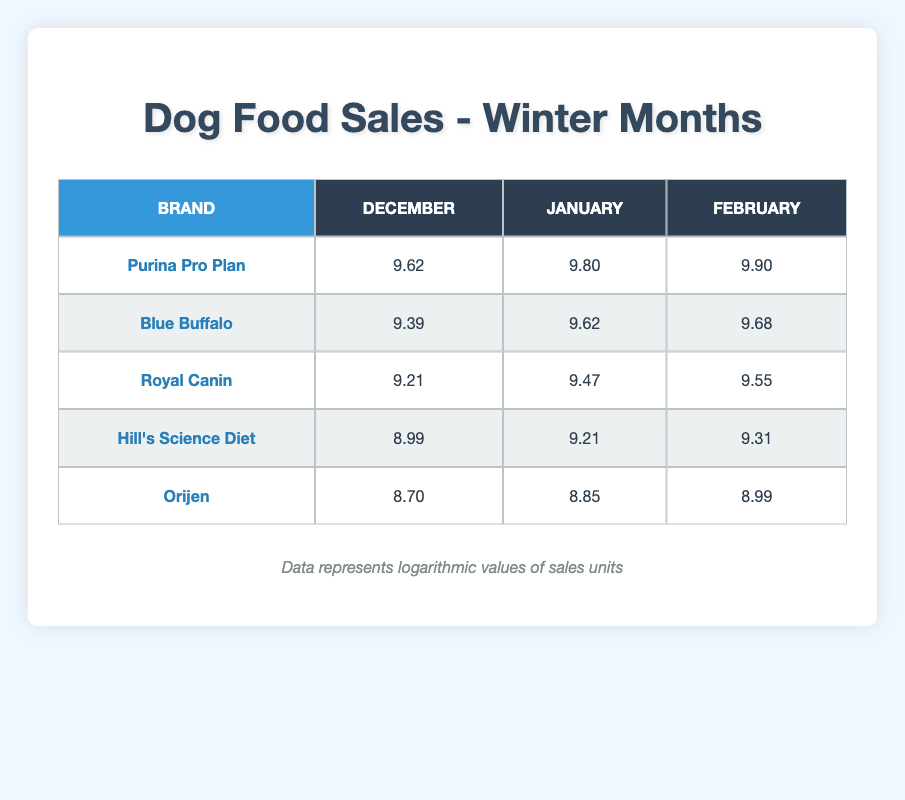What are the logarithmic sales units of Purina Pro Plan in February? The table shows that for Purina Pro Plan in February, the logarithmic sales units are 9.90.
Answer: 9.90 Which brand had the highest logarithmic sales in January? In January, Purina Pro Plan had the highest logarithmic sales units at 9.80, compared to Blue Buffalo with 9.62, Royal Canin with 9.47, Hill's Science Diet with 9.21, and Orijen with 8.85.
Answer: Purina Pro Plan What is the difference in logarithmic sales units between Royal Canin in December and February? Royal Canin has logarithmic sales units of 9.21 in December and 9.55 in February. The difference is 9.55 - 9.21 = 0.34.
Answer: 0.34 Is the logarithmic sales unit of Blue Buffalo higher in February than Hill's Science Diet in January? Blue Buffalo has a logarithmic sales unit of 9.68 in February, whereas Hill's Science Diet has 9.21 in January. Since 9.68 is greater than 9.21, the statement is true.
Answer: Yes What is the average logarithmic sales for Hill's Science Diet across all winter months? The logarithmic sales for Hill's Science Diet are 8.99 for December, 9.21 for January, and 9.31 for February. The average is (8.99 + 9.21 + 9.31) / 3 = 9.17.
Answer: 9.17 Which brand showed a consistent increase in logarithmic sales from December to February? Purina Pro Plan shows an increase from 9.62 in December, to 9.80 in January, and 9.90 in February, indicating a consistent upward trend.
Answer: Purina Pro Plan Was the logarithmic sales unit of Orijen higher in January or December? Orijen's logarithmic sales unit in January is 8.85, while in December it is 8.70. Since 8.85 is greater than 8.70, Orijen had higher sales in January.
Answer: January How many different brands are represented in December's logarithmic sales? The table shows five distinct brands noted under the December column: Purina Pro Plan, Blue Buffalo, Royal Canin, Hill's Science Diet, and Orijen.
Answer: 5 